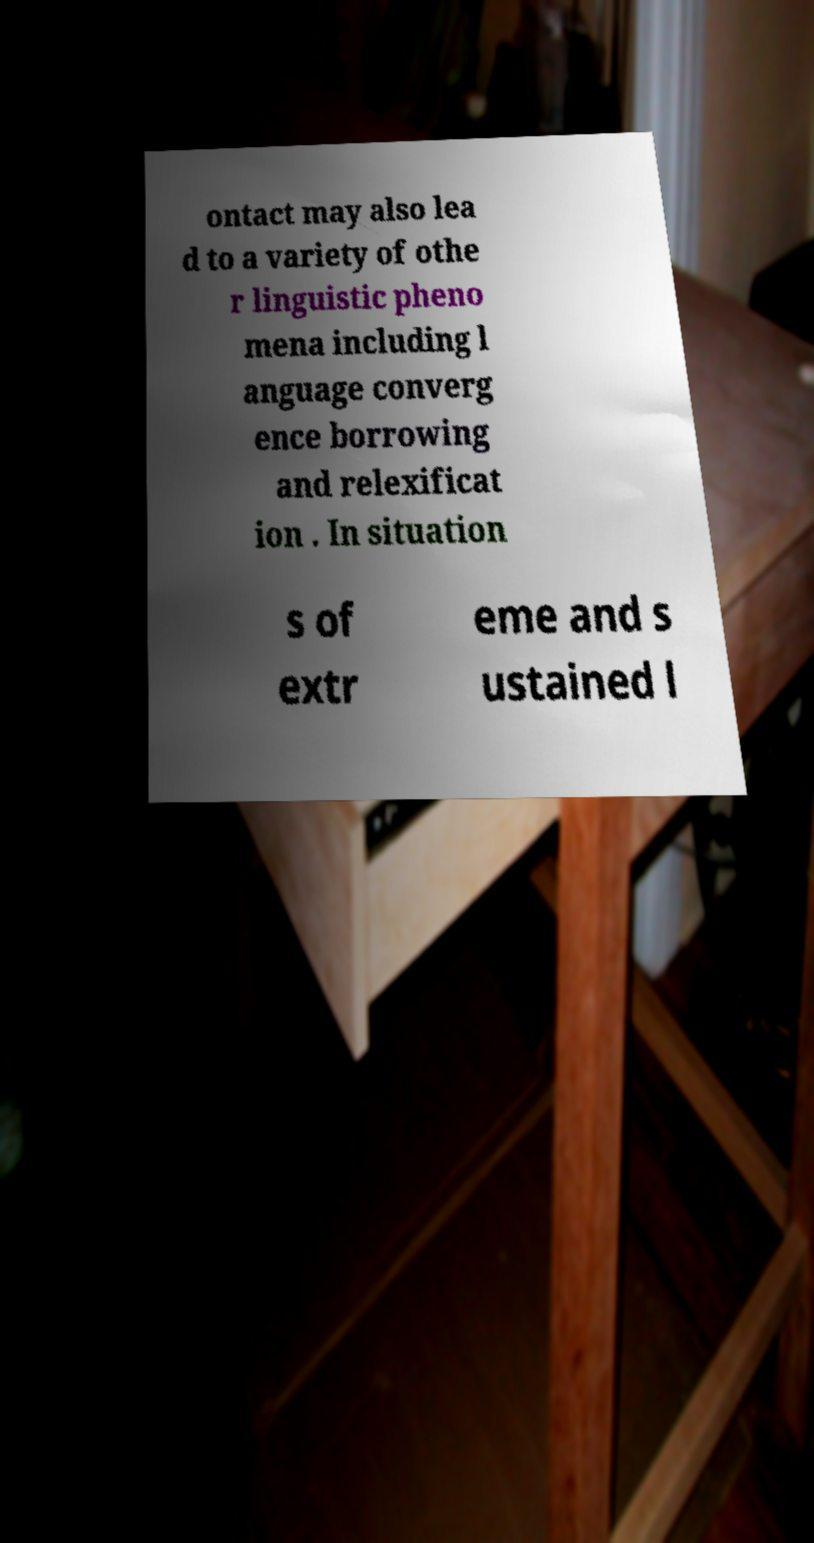Could you extract and type out the text from this image? ontact may also lea d to a variety of othe r linguistic pheno mena including l anguage converg ence borrowing and relexificat ion . In situation s of extr eme and s ustained l 